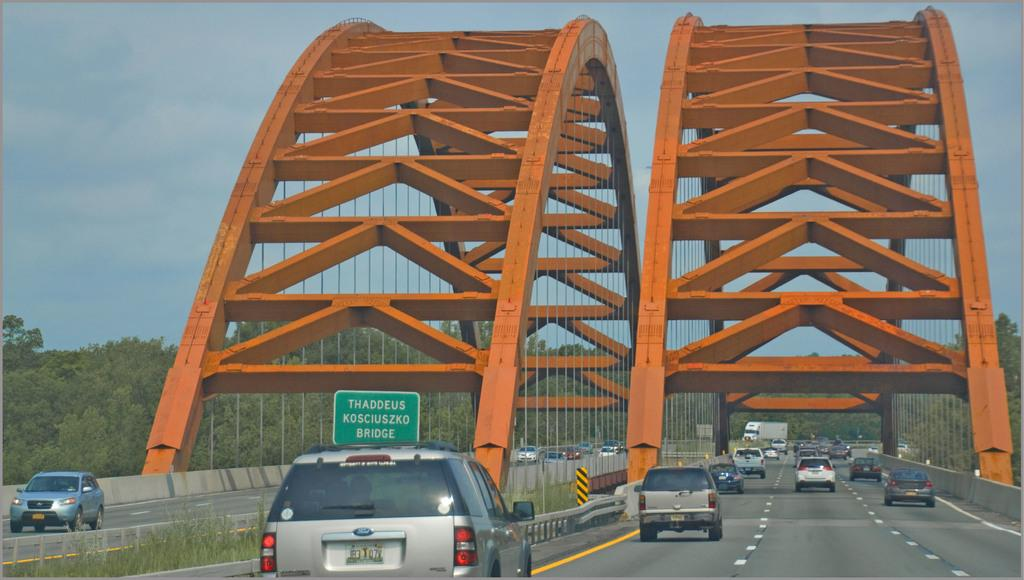What is happening on the bridges in the image? There are cars moving on the bridges in the image. What is the shape of the bridges? The bridges have an arch shape. What can be seen in the background of the image? There are trees and the sky visible in the background of the image. How quiet is the environment around the bridges in the image? The provided facts do not give any information about the noise level or the quietness of the environment around the bridges. 